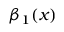Convert formula to latex. <formula><loc_0><loc_0><loc_500><loc_500>\beta _ { 1 } ( x )</formula> 